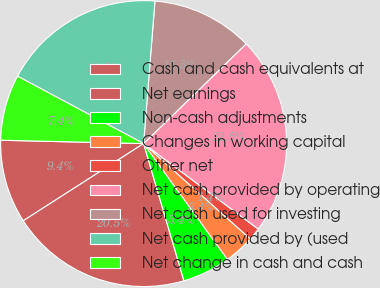Convert chart. <chart><loc_0><loc_0><loc_500><loc_500><pie_chart><fcel>Cash and cash equivalents at<fcel>Net earnings<fcel>Non-cash adjustments<fcel>Changes in working capital<fcel>Other net<fcel>Net cash provided by operating<fcel>Net cash used for investing<fcel>Net cash provided by (used<fcel>Net change in cash and cash<nl><fcel>9.45%<fcel>20.47%<fcel>5.43%<fcel>3.42%<fcel>1.4%<fcel>22.48%<fcel>11.46%<fcel>18.45%<fcel>7.44%<nl></chart> 